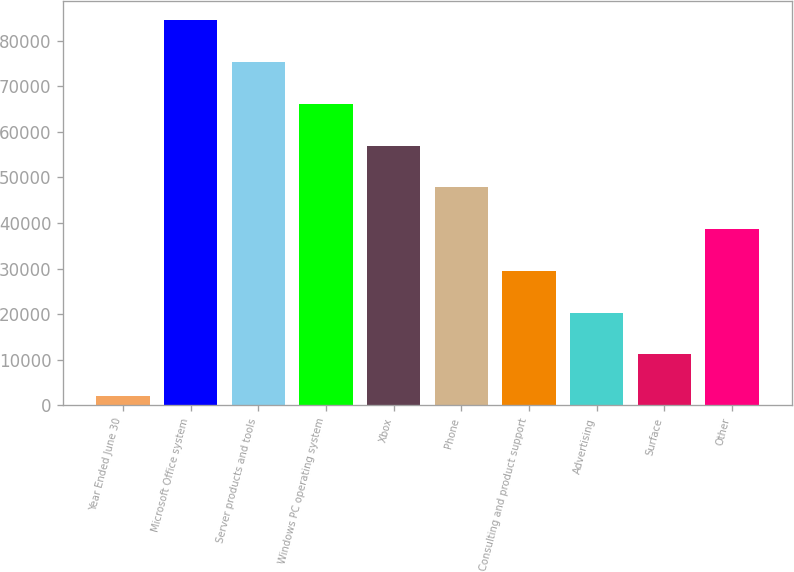<chart> <loc_0><loc_0><loc_500><loc_500><bar_chart><fcel>Year Ended June 30<fcel>Microsoft Office system<fcel>Server products and tools<fcel>Windows PC operating system<fcel>Xbox<fcel>Phone<fcel>Consulting and product support<fcel>Advertising<fcel>Surface<fcel>Other<nl><fcel>2015<fcel>84423.5<fcel>75267<fcel>66110.5<fcel>56954<fcel>47797.5<fcel>29484.5<fcel>20328<fcel>11171.5<fcel>38641<nl></chart> 